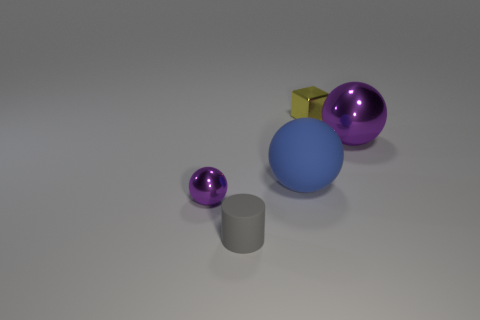What number of other things are made of the same material as the small yellow cube?
Offer a very short reply. 2. There is a thing right of the yellow block; is it the same shape as the purple thing on the left side of the small gray cylinder?
Your answer should be very brief. Yes. Is the material of the tiny yellow object the same as the big purple sphere?
Give a very brief answer. Yes. What size is the purple thing that is on the left side of the purple ball right of the object that is in front of the tiny sphere?
Keep it short and to the point. Small. What number of other things are there of the same color as the big metal thing?
Your answer should be very brief. 1. There is a shiny thing that is the same size as the yellow block; what shape is it?
Offer a very short reply. Sphere. What number of big objects are metallic spheres or blue things?
Offer a terse response. 2. There is a purple sphere left of the sphere on the right side of the cube; is there a thing that is in front of it?
Provide a short and direct response. Yes. Are there any purple balls that have the same size as the gray thing?
Your answer should be very brief. Yes. What is the material of the purple sphere that is the same size as the blue matte thing?
Provide a short and direct response. Metal. 